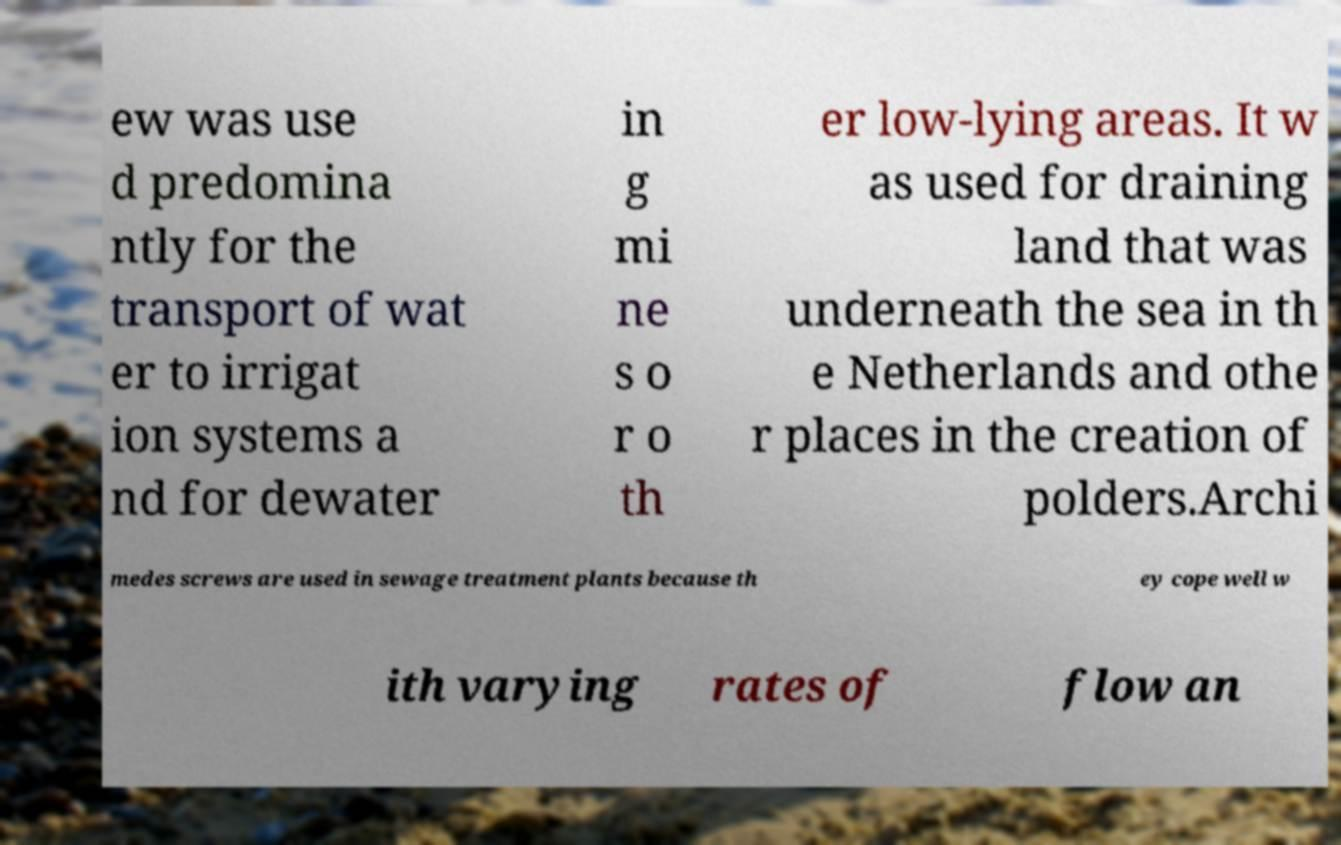Can you accurately transcribe the text from the provided image for me? ew was use d predomina ntly for the transport of wat er to irrigat ion systems a nd for dewater in g mi ne s o r o th er low-lying areas. It w as used for draining land that was underneath the sea in th e Netherlands and othe r places in the creation of polders.Archi medes screws are used in sewage treatment plants because th ey cope well w ith varying rates of flow an 